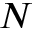Convert formula to latex. <formula><loc_0><loc_0><loc_500><loc_500>N</formula> 